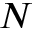Convert formula to latex. <formula><loc_0><loc_0><loc_500><loc_500>N</formula> 